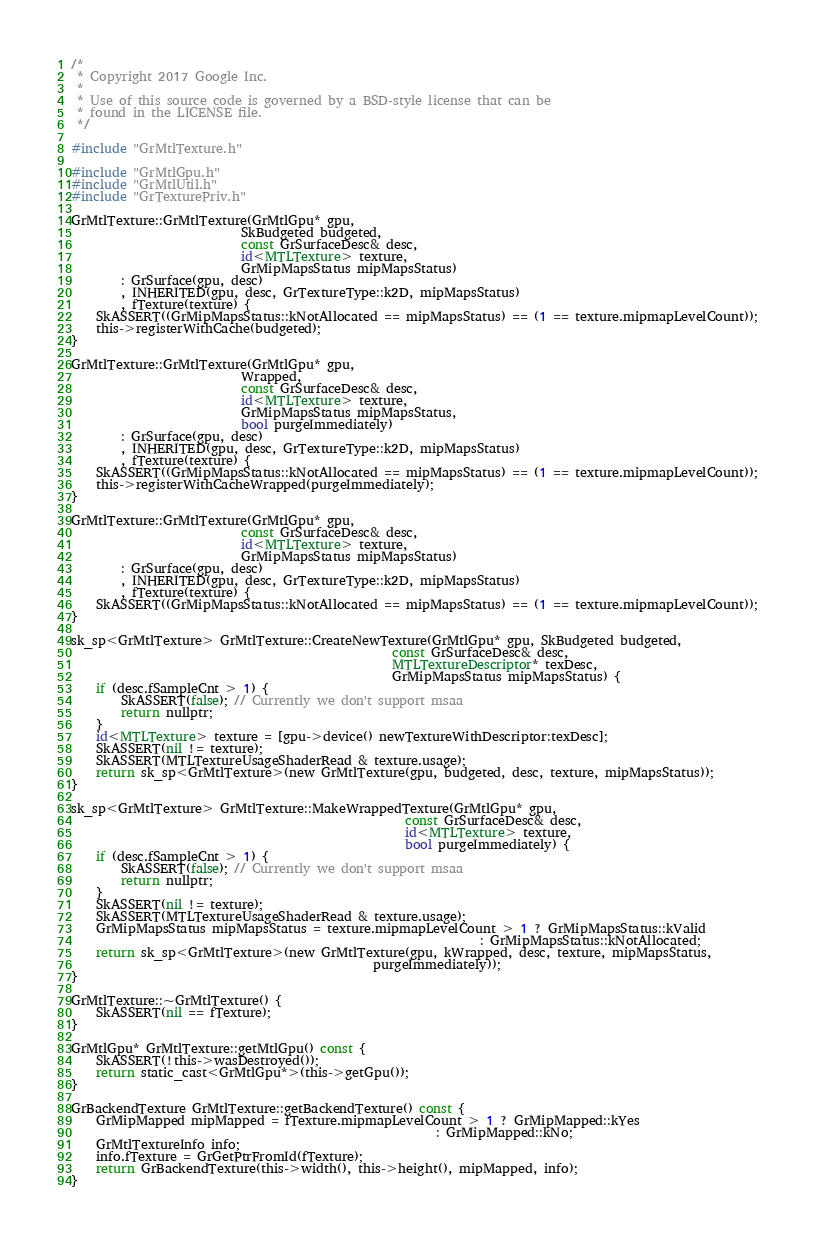Convert code to text. <code><loc_0><loc_0><loc_500><loc_500><_ObjectiveC_>/*
 * Copyright 2017 Google Inc.
 *
 * Use of this source code is governed by a BSD-style license that can be
 * found in the LICENSE file.
 */

#include "GrMtlTexture.h"

#include "GrMtlGpu.h"
#include "GrMtlUtil.h"
#include "GrTexturePriv.h"

GrMtlTexture::GrMtlTexture(GrMtlGpu* gpu,
                           SkBudgeted budgeted,
                           const GrSurfaceDesc& desc,
                           id<MTLTexture> texture,
                           GrMipMapsStatus mipMapsStatus)
        : GrSurface(gpu, desc)
        , INHERITED(gpu, desc, GrTextureType::k2D, mipMapsStatus)
        , fTexture(texture) {
    SkASSERT((GrMipMapsStatus::kNotAllocated == mipMapsStatus) == (1 == texture.mipmapLevelCount));
    this->registerWithCache(budgeted);
}

GrMtlTexture::GrMtlTexture(GrMtlGpu* gpu,
                           Wrapped,
                           const GrSurfaceDesc& desc,
                           id<MTLTexture> texture,
                           GrMipMapsStatus mipMapsStatus,
                           bool purgeImmediately)
        : GrSurface(gpu, desc)
        , INHERITED(gpu, desc, GrTextureType::k2D, mipMapsStatus)
        , fTexture(texture) {
    SkASSERT((GrMipMapsStatus::kNotAllocated == mipMapsStatus) == (1 == texture.mipmapLevelCount));
    this->registerWithCacheWrapped(purgeImmediately);
}

GrMtlTexture::GrMtlTexture(GrMtlGpu* gpu,
                           const GrSurfaceDesc& desc,
                           id<MTLTexture> texture,
                           GrMipMapsStatus mipMapsStatus)
        : GrSurface(gpu, desc)
        , INHERITED(gpu, desc, GrTextureType::k2D, mipMapsStatus)
        , fTexture(texture) {
    SkASSERT((GrMipMapsStatus::kNotAllocated == mipMapsStatus) == (1 == texture.mipmapLevelCount));
}

sk_sp<GrMtlTexture> GrMtlTexture::CreateNewTexture(GrMtlGpu* gpu, SkBudgeted budgeted,
                                                   const GrSurfaceDesc& desc,
                                                   MTLTextureDescriptor* texDesc,
                                                   GrMipMapsStatus mipMapsStatus) {
    if (desc.fSampleCnt > 1) {
        SkASSERT(false); // Currently we don't support msaa
        return nullptr;
    }
    id<MTLTexture> texture = [gpu->device() newTextureWithDescriptor:texDesc];
    SkASSERT(nil != texture);
    SkASSERT(MTLTextureUsageShaderRead & texture.usage);
    return sk_sp<GrMtlTexture>(new GrMtlTexture(gpu, budgeted, desc, texture, mipMapsStatus));
}

sk_sp<GrMtlTexture> GrMtlTexture::MakeWrappedTexture(GrMtlGpu* gpu,
                                                     const GrSurfaceDesc& desc,
                                                     id<MTLTexture> texture,
                                                     bool purgeImmediately) {
    if (desc.fSampleCnt > 1) {
        SkASSERT(false); // Currently we don't support msaa
        return nullptr;
    }
    SkASSERT(nil != texture);
    SkASSERT(MTLTextureUsageShaderRead & texture.usage);
    GrMipMapsStatus mipMapsStatus = texture.mipmapLevelCount > 1 ? GrMipMapsStatus::kValid
                                                                 : GrMipMapsStatus::kNotAllocated;
    return sk_sp<GrMtlTexture>(new GrMtlTexture(gpu, kWrapped, desc, texture, mipMapsStatus,
                                                purgeImmediately));
}

GrMtlTexture::~GrMtlTexture() {
    SkASSERT(nil == fTexture);
}

GrMtlGpu* GrMtlTexture::getMtlGpu() const {
    SkASSERT(!this->wasDestroyed());
    return static_cast<GrMtlGpu*>(this->getGpu());
}

GrBackendTexture GrMtlTexture::getBackendTexture() const {
    GrMipMapped mipMapped = fTexture.mipmapLevelCount > 1 ? GrMipMapped::kYes
                                                          : GrMipMapped::kNo;
    GrMtlTextureInfo info;
    info.fTexture = GrGetPtrFromId(fTexture);
    return GrBackendTexture(this->width(), this->height(), mipMapped, info);
}

</code> 